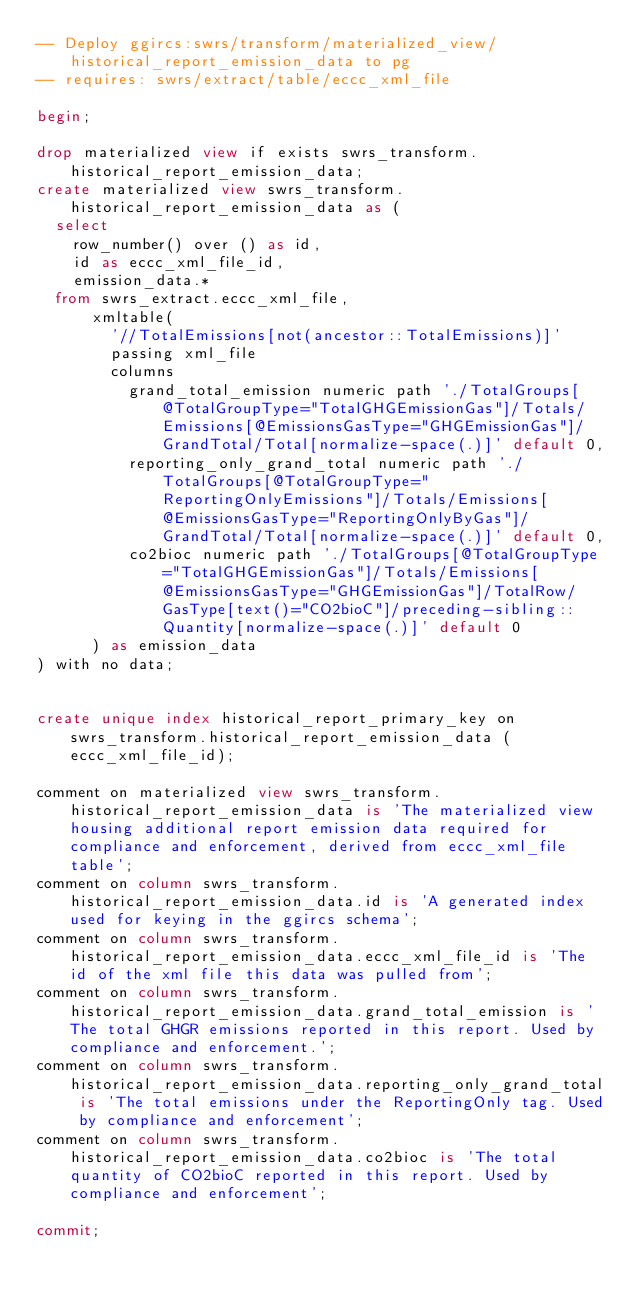Convert code to text. <code><loc_0><loc_0><loc_500><loc_500><_SQL_>-- Deploy ggircs:swrs/transform/materialized_view/historical_report_emission_data to pg
-- requires: swrs/extract/table/eccc_xml_file

begin;

drop materialized view if exists swrs_transform.historical_report_emission_data;
create materialized view swrs_transform.historical_report_emission_data as (
  select
    row_number() over () as id,
    id as eccc_xml_file_id,
    emission_data.*
  from swrs_extract.eccc_xml_file,
      xmltable(
        '//TotalEmissions[not(ancestor::TotalEmissions)]'
        passing xml_file
        columns
          grand_total_emission numeric path './TotalGroups[@TotalGroupType="TotalGHGEmissionGas"]/Totals/Emissions[@EmissionsGasType="GHGEmissionGas"]/GrandTotal/Total[normalize-space(.)]' default 0,
          reporting_only_grand_total numeric path './TotalGroups[@TotalGroupType="ReportingOnlyEmissions"]/Totals/Emissions[@EmissionsGasType="ReportingOnlyByGas"]/GrandTotal/Total[normalize-space(.)]' default 0,
          co2bioc numeric path './TotalGroups[@TotalGroupType="TotalGHGEmissionGas"]/Totals/Emissions[@EmissionsGasType="GHGEmissionGas"]/TotalRow/GasType[text()="CO2bioC"]/preceding-sibling::Quantity[normalize-space(.)]' default 0
      ) as emission_data
) with no data;


create unique index historical_report_primary_key on swrs_transform.historical_report_emission_data (eccc_xml_file_id);

comment on materialized view swrs_transform.historical_report_emission_data is 'The materialized view housing additional report emission data required for compliance and enforcement, derived from eccc_xml_file table';
comment on column swrs_transform.historical_report_emission_data.id is 'A generated index used for keying in the ggircs schema';
comment on column swrs_transform.historical_report_emission_data.eccc_xml_file_id is 'The id of the xml file this data was pulled from';
comment on column swrs_transform.historical_report_emission_data.grand_total_emission is 'The total GHGR emissions reported in this report. Used by compliance and enforcement.';
comment on column swrs_transform.historical_report_emission_data.reporting_only_grand_total is 'The total emissions under the ReportingOnly tag. Used by compliance and enforcement';
comment on column swrs_transform.historical_report_emission_data.co2bioc is 'The total quantity of CO2bioC reported in this report. Used by compliance and enforcement';

commit;
</code> 